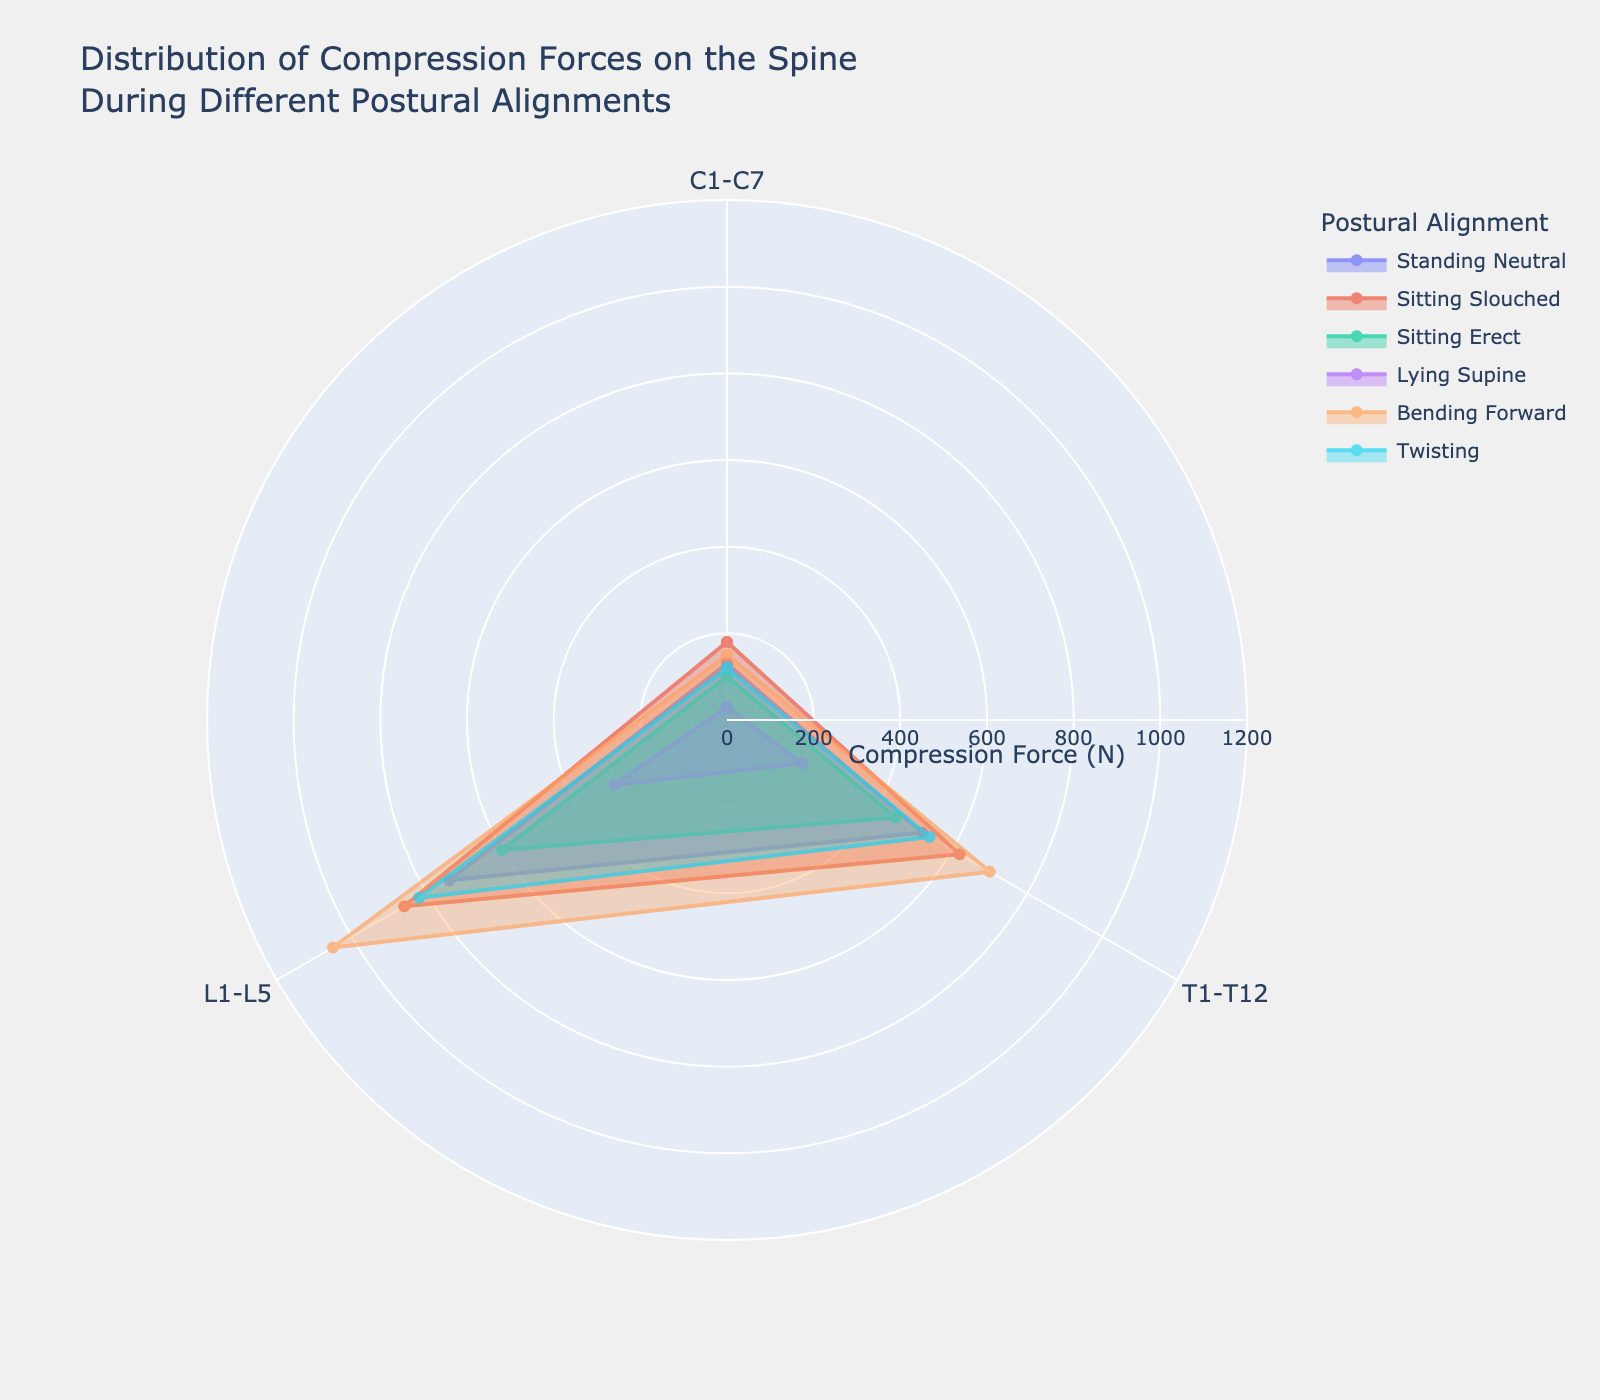Which postural alignment has the highest compression force at the lumbar spine? To answer this, observe the points on the radial axis for each alignment; look for the largest value at the lumbar spine (L1-L5). Bending Forward shows the highest value at the lumbar spine, reaching 1050 N.
Answer: Bending Forward Which postural alignment, on average, has the lowest compression forces across all spinal levels? Calculate the average compression force for each alignment. The averages are: Standing Neutral (463.3 N), Sitting Slouched (553.3 N), Sitting Erect (383.3 N), Lying Supine (176.7 N), Bending Forward (633.3 N), Twisting (493.3 N). Lying Supine has the lowest average.
Answer: Lying Supine How does the compression force at C1-C7 in Sitting Slouched compare to that in Standing Neutral? Check the values of compression forces at C1-C7 for both Sitting Slouched and Standing Neutral. Sitting Slouched shows 180 N and Standing Neutral shows 130 N, indicating that Sitting Slouched exerts more force.
Answer: Sitting Slouched has higher force Which spinal level experiences the highest compression force in Sitting Erect posture? Evaluate the compression forces across the given spinal levels in the Sitting Erect posture: C1-C7 (100 N), T1-T12 (450 N), L1-L5 (600 N). The lumbar spine (L1-L5) experiences the highest force.
Answer: L1-L5 What is the difference in compression force at T1-T12 between Bending Forward and Twisting postures? Subtract the compression force in the Twisting posture (540 N) from the Bending Forward posture (700 N) at T1-T12. The difference is 700 N - 540 N = 160 N.
Answer: 160 N In which posture does the cervical spine (C1-C7) experience the least compression force? Compare the compression forces at C1-C7 across all postural alignments: Lying Supine shows 30 N, which is the least force.
Answer: Lying Supine Which spinal level exhibits the greatest range of compression forces across different postures? Calculate the range (max - min) of compression forces at each spinal level. C1-C7 ranges from 30 N to 180 N (range = 150 N), T1-T12 ranges from 200 N to 700 N (range = 500 N), L1-L5 ranges from 300 N to 1050 N (range = 750 N). L1-L5 shows the highest range.
Answer: L1-L5 